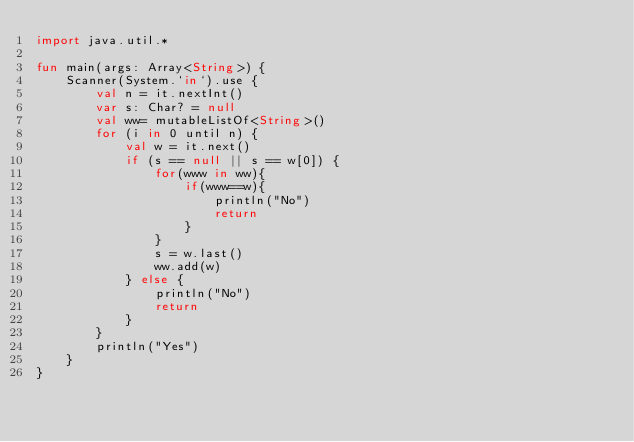<code> <loc_0><loc_0><loc_500><loc_500><_Kotlin_>import java.util.*

fun main(args: Array<String>) {
    Scanner(System.`in`).use {
        val n = it.nextInt()
        var s: Char? = null
        val ww= mutableListOf<String>()
        for (i in 0 until n) {
            val w = it.next()
            if (s == null || s == w[0]) {
                for(www in ww){
                    if(www==w){
                        println("No")
                        return
                    }
                }
                s = w.last()
                ww.add(w)
            } else {
                println("No")
                return
            }
        }
        println("Yes")
    }
}
</code> 